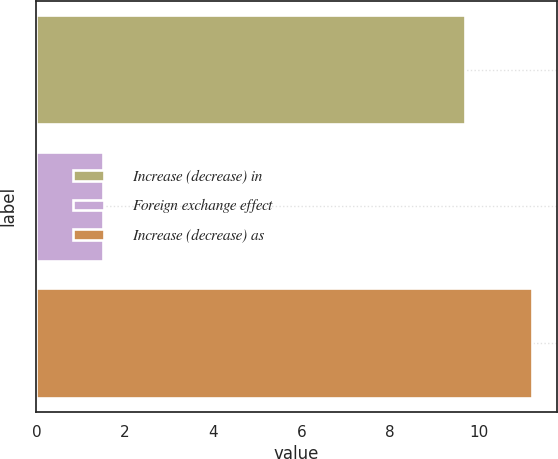Convert chart to OTSL. <chart><loc_0><loc_0><loc_500><loc_500><bar_chart><fcel>Increase (decrease) in<fcel>Foreign exchange effect<fcel>Increase (decrease) as<nl><fcel>9.7<fcel>1.5<fcel>11.2<nl></chart> 